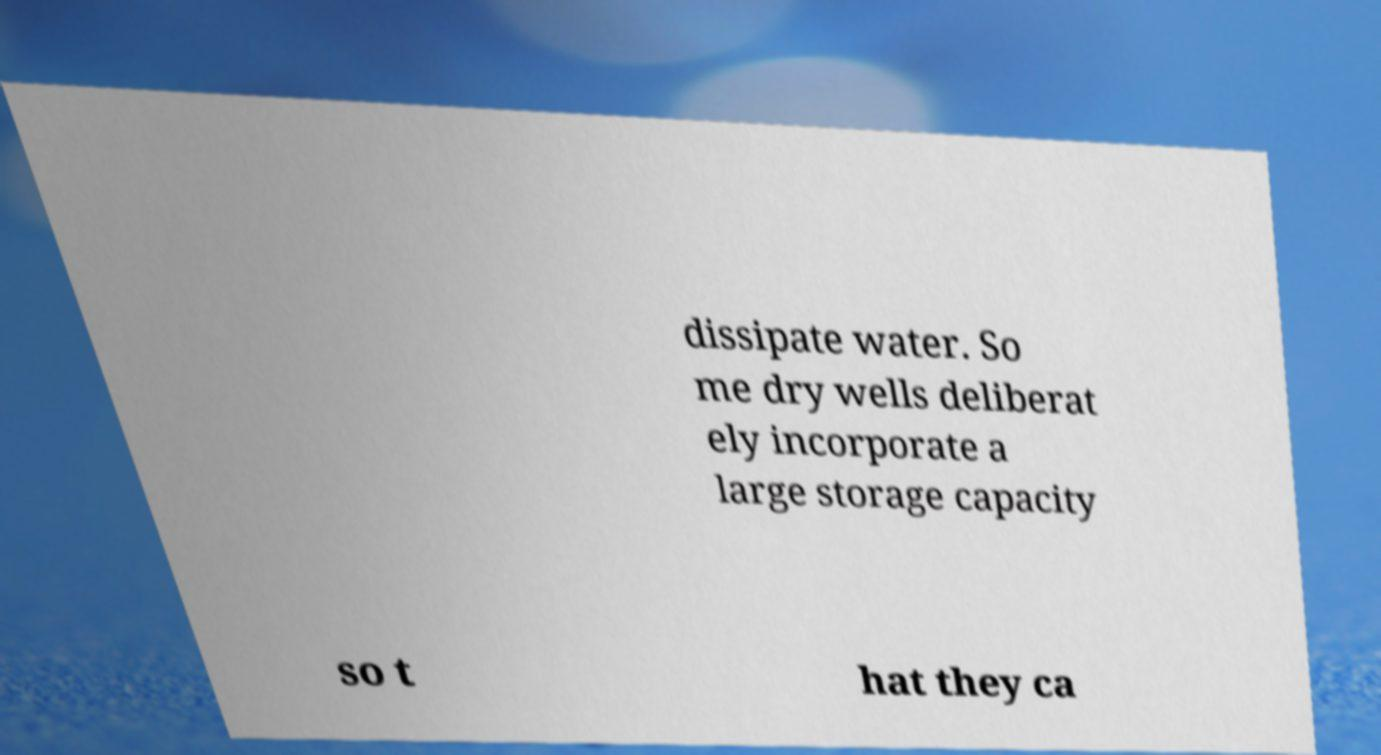Can you read and provide the text displayed in the image?This photo seems to have some interesting text. Can you extract and type it out for me? dissipate water. So me dry wells deliberat ely incorporate a large storage capacity so t hat they ca 